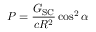Convert formula to latex. <formula><loc_0><loc_0><loc_500><loc_500>P = { \frac { G _ { S C } } { c R ^ { 2 } } } \cos ^ { 2 } \alpha</formula> 